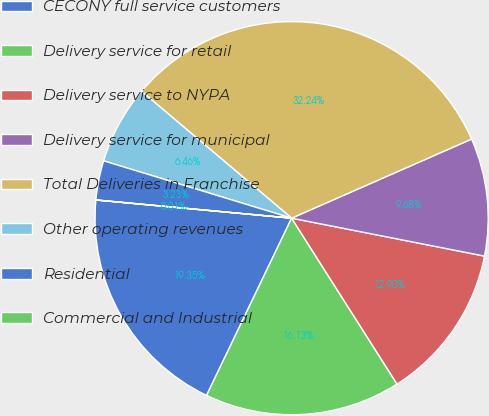Convert chart to OTSL. <chart><loc_0><loc_0><loc_500><loc_500><pie_chart><fcel>CECONY full service customers<fcel>Delivery service for retail<fcel>Delivery service to NYPA<fcel>Delivery service for municipal<fcel>Total Deliveries in Franchise<fcel>Other operating revenues<fcel>Residential<fcel>Commercial and Industrial<nl><fcel>19.35%<fcel>16.13%<fcel>12.9%<fcel>9.68%<fcel>32.24%<fcel>6.46%<fcel>3.23%<fcel>0.01%<nl></chart> 